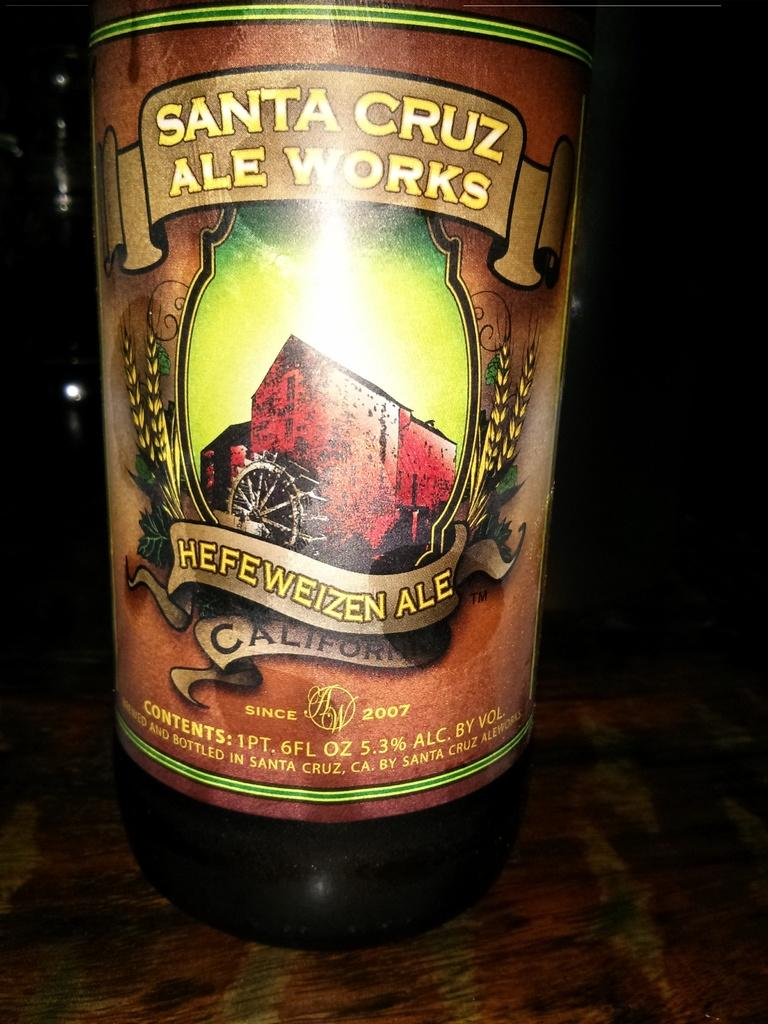What is on the bottle in the image? There is a sticker on the bottle in the image. What is the bottle placed on? The bottle is on an object in the image. How would you describe the overall lighting in the image? The background of the image is dark. What type of veil is draped over the bottle in the image? There is no veil present in the image; it only features a sticker on a bottle. What kind of cream is being used to decorate the bottle in the image? There is no cream present in the image; the only decoration mentioned is the sticker. 